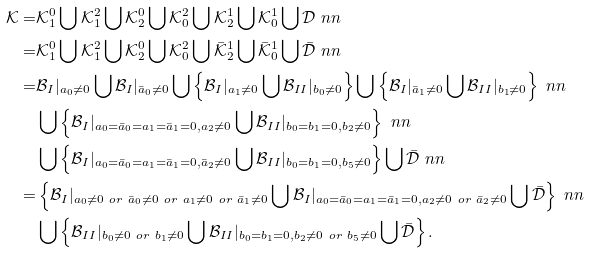<formula> <loc_0><loc_0><loc_500><loc_500>\mathcal { K } = & \mathcal { K } _ { 1 } ^ { 0 } \bigcup \mathcal { K } _ { 1 } ^ { 2 } \bigcup \mathcal { K } _ { 2 } ^ { 0 } \bigcup \mathcal { K } _ { 0 } ^ { 2 } \bigcup \mathcal { K } _ { 2 } ^ { 1 } \bigcup \mathcal { K } _ { 0 } ^ { 1 } \bigcup \mathcal { D } \ n n \\ = & \mathcal { K } _ { 1 } ^ { 0 } \bigcup \mathcal { K } _ { 1 } ^ { 2 } \bigcup \mathcal { K } _ { 2 } ^ { 0 } \bigcup \mathcal { K } _ { 0 } ^ { 2 } \bigcup \bar { \mathcal { K } } _ { 2 } ^ { 1 } \bigcup \bar { \mathcal { K } } _ { 0 } ^ { 1 } \bigcup \bar { \mathcal { D } } \ n n \\ = & \mathcal { B } _ { I } | _ { a _ { 0 } \neq 0 } \bigcup \mathcal { B } _ { I } | _ { \bar { a } _ { 0 } \neq 0 } \bigcup \left \{ \mathcal { B } _ { I } | _ { a _ { 1 } \neq 0 } \bigcup \mathcal { B } _ { I I } | _ { b _ { 0 } \neq 0 } \right \} \bigcup \left \{ \mathcal { B } _ { I } | _ { \bar { a } _ { 1 } \neq 0 } \bigcup \mathcal { B } _ { I I } | _ { b _ { 1 } \neq 0 } \right \} \ n n \\ & \bigcup \left \{ \mathcal { B } _ { I } | _ { a _ { 0 } = \bar { a } _ { 0 } = a _ { 1 } = \bar { a } _ { 1 } = 0 , a _ { 2 } \neq 0 } \bigcup \mathcal { B } _ { I I } | _ { b _ { 0 } = b _ { 1 } = 0 , b _ { 2 } \neq 0 } \right \} \ n n \\ & \bigcup \left \{ \mathcal { B } _ { I } | _ { a _ { 0 } = \bar { a } _ { 0 } = a _ { 1 } = \bar { a } _ { 1 } = 0 , \bar { a } _ { 2 } \neq 0 } \bigcup \mathcal { B } _ { I I } | _ { b _ { 0 } = b _ { 1 } = 0 , b _ { 5 } \neq 0 } \right \} \bigcup \bar { \mathcal { D } } \ n n \\ = & \left \{ \mathcal { B } _ { I } | _ { a _ { 0 } \neq 0 \ o r \ \bar { a } _ { 0 } \neq 0 \ o r \ a _ { 1 } \neq 0 \ o r \ \bar { a } _ { 1 } \neq 0 } \bigcup \mathcal { B } _ { I } | _ { a _ { 0 } = \bar { a } _ { 0 } = a _ { 1 } = \bar { a } _ { 1 } = 0 , a _ { 2 } \neq 0 \ o r \ \bar { a } _ { 2 } \neq 0 } \bigcup \bar { \mathcal { D } } \right \} \ n n \\ & \bigcup \left \{ \mathcal { B } _ { I I } | _ { b _ { 0 } \neq 0 \ o r \ b _ { 1 } \neq 0 } \bigcup \mathcal { B } _ { I I } | _ { b _ { 0 } = b _ { 1 } = 0 , b _ { 2 } \neq 0 \ o r \ b _ { 5 } \neq 0 } \bigcup \bar { \mathcal { D } } \right \} .</formula> 